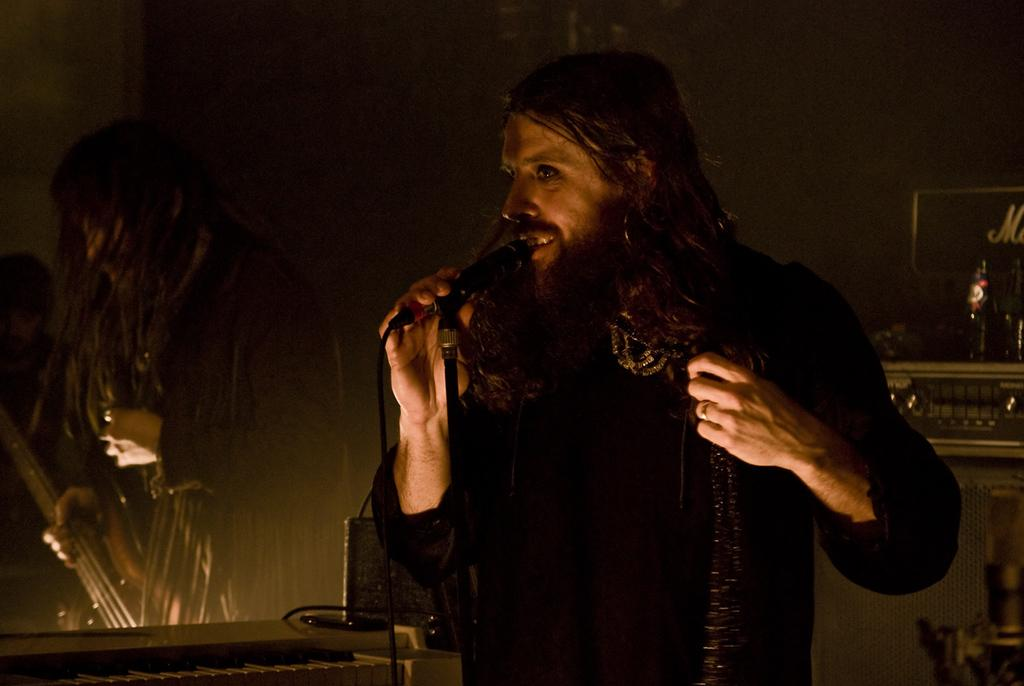What is the main subject of the picture? The main subject of the picture is a man. What is the man holding in the picture? The man is holding a microphone. What is the man doing in the picture? The man is singing. What type of skirt is the man wearing in the image? The man is not wearing a skirt in the image; he is wearing clothing appropriate for singing. How many knees can be seen in the image? There is no specific focus on knees in the image, so it is not possible to determine the number of knees visible. 